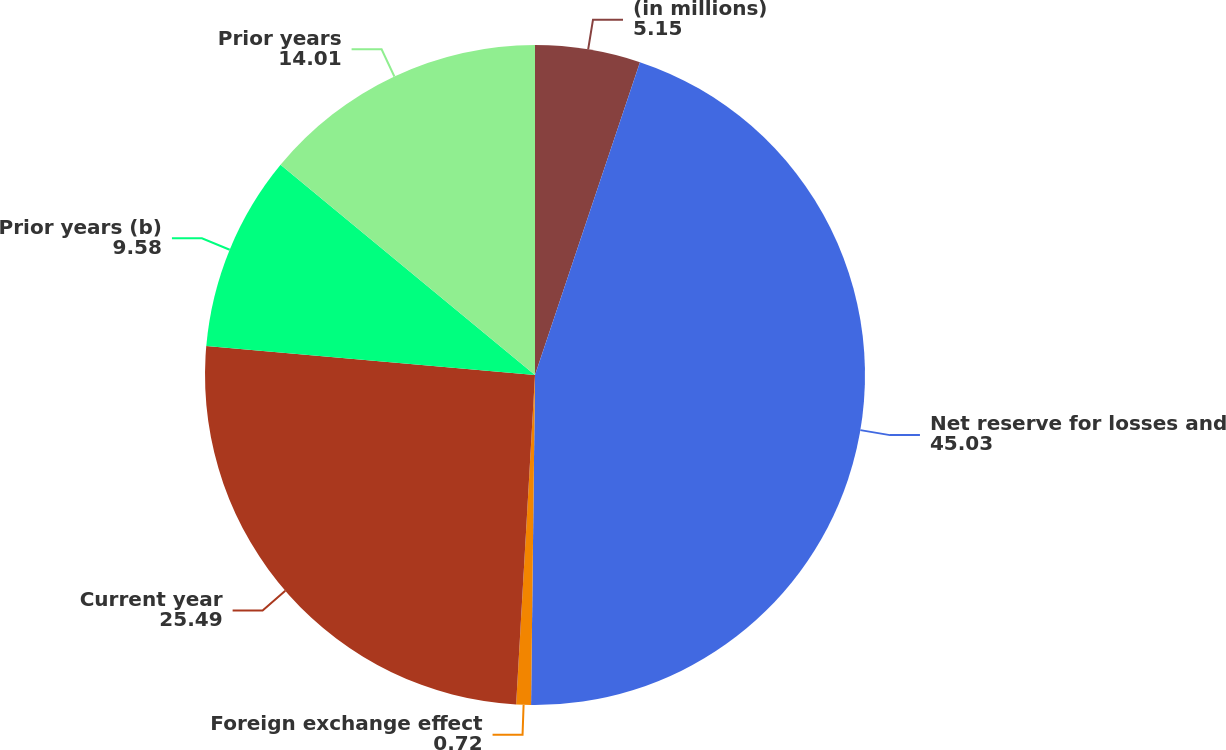<chart> <loc_0><loc_0><loc_500><loc_500><pie_chart><fcel>(in millions)<fcel>Net reserve for losses and<fcel>Foreign exchange effect<fcel>Current year<fcel>Prior years (b)<fcel>Prior years<nl><fcel>5.15%<fcel>45.03%<fcel>0.72%<fcel>25.49%<fcel>9.58%<fcel>14.01%<nl></chart> 